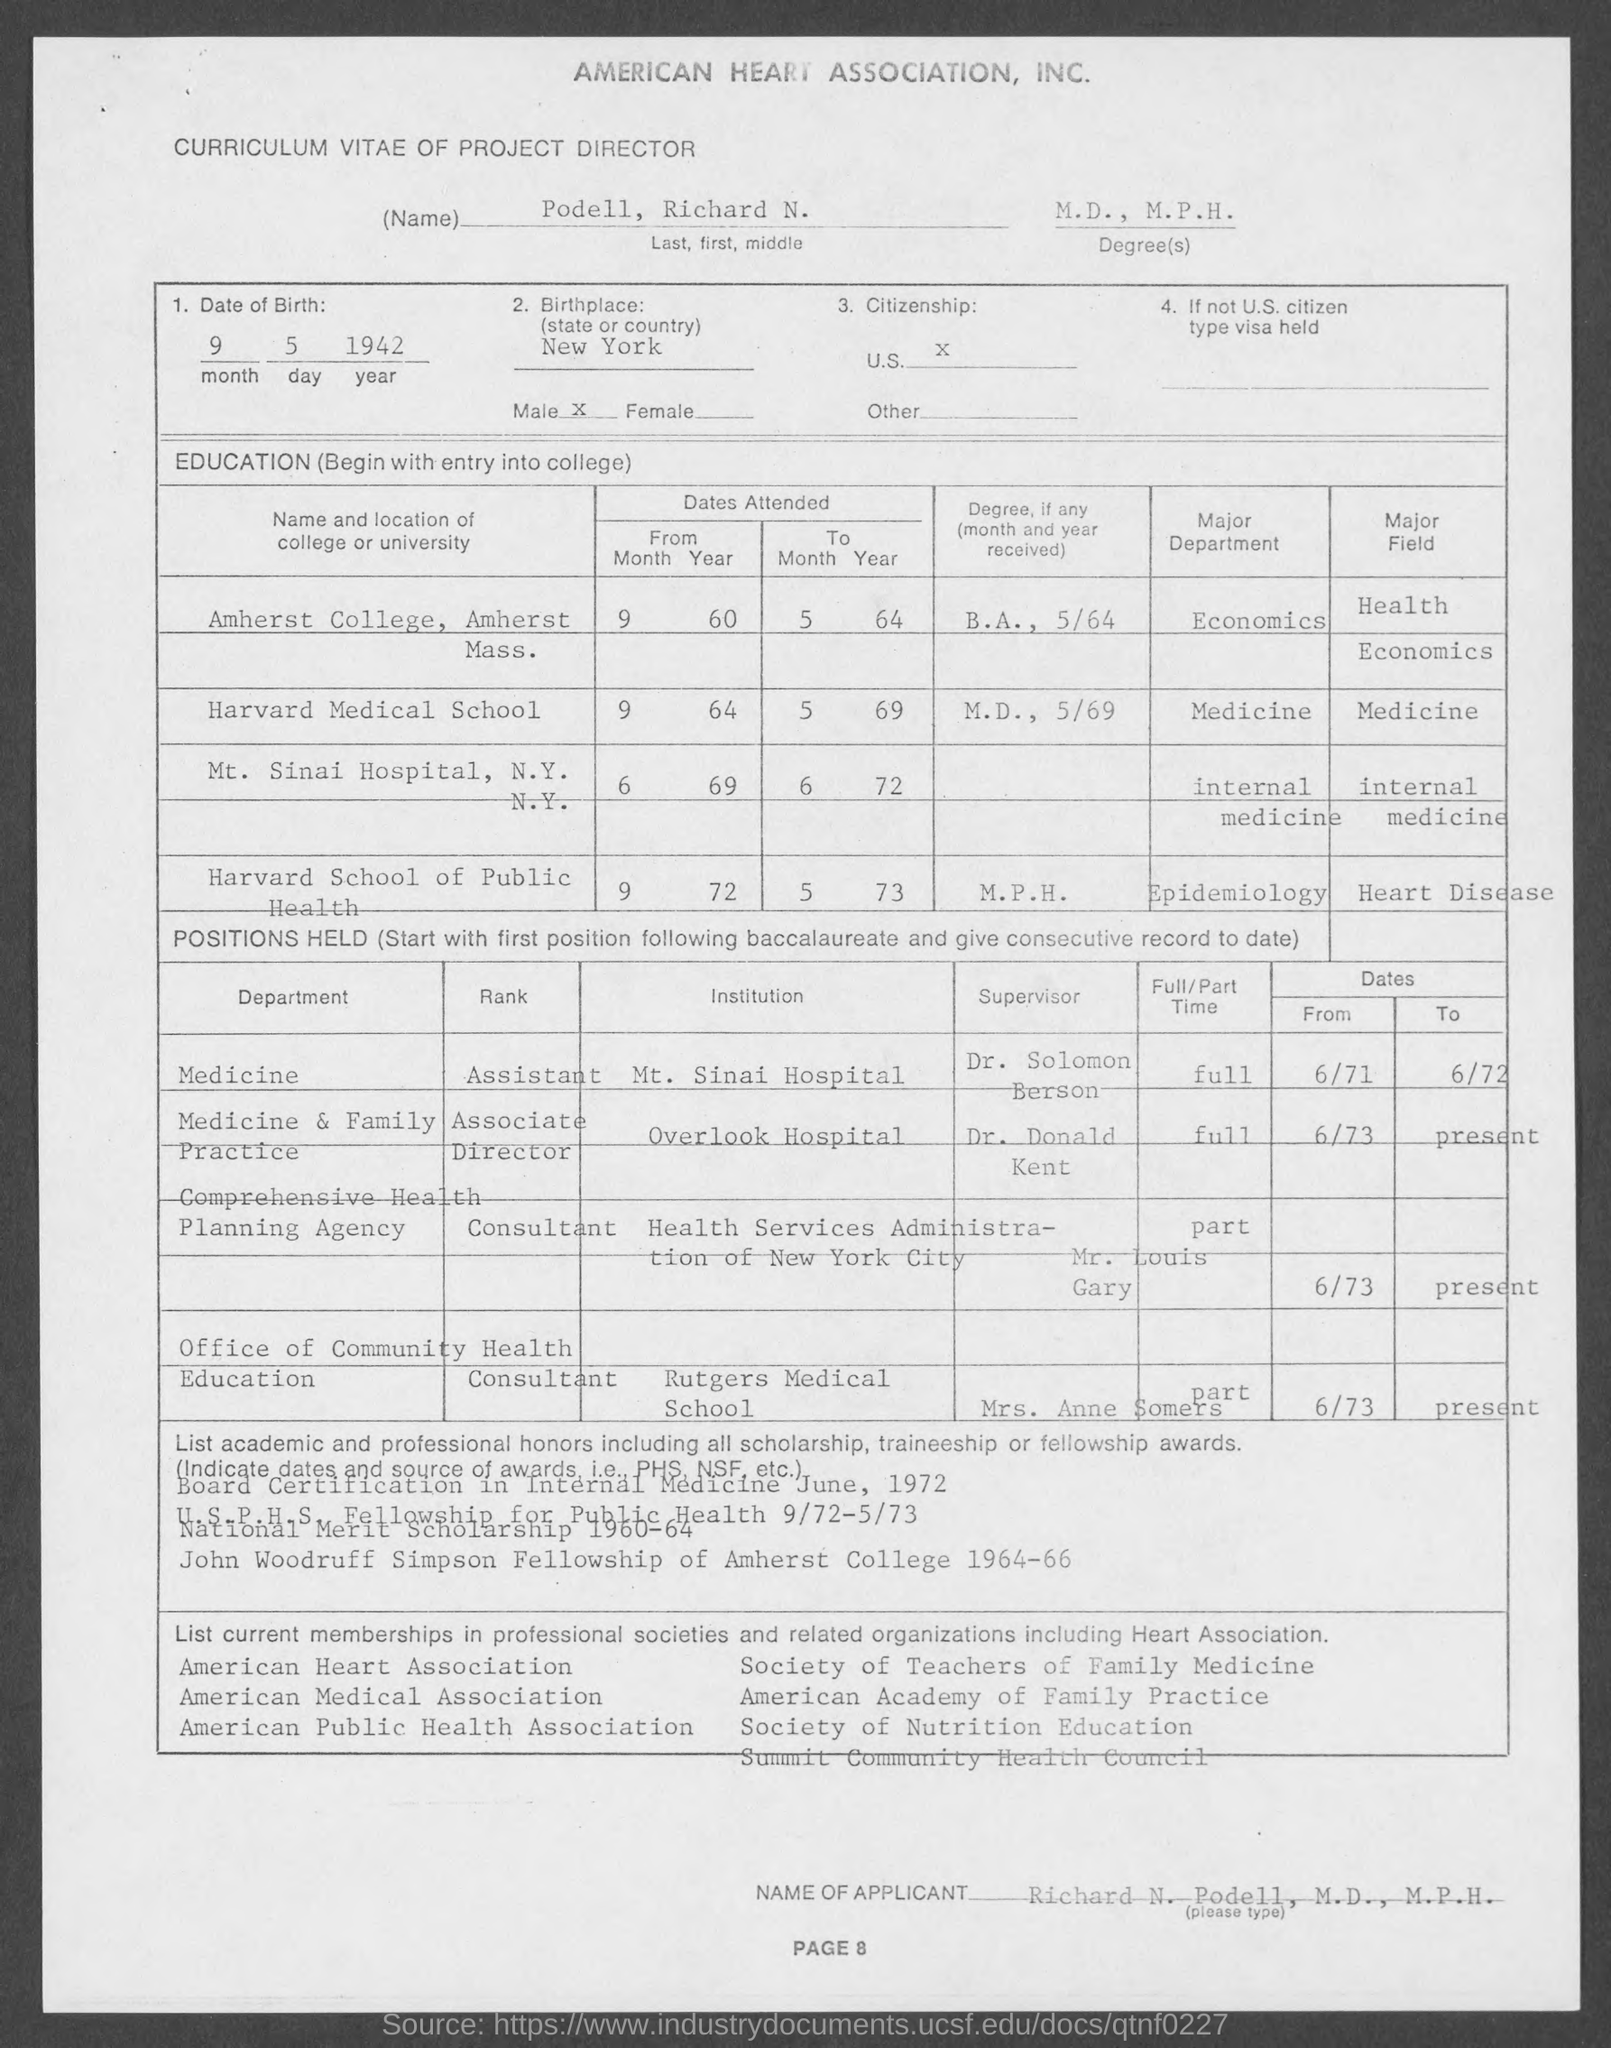List a handful of essential elements in this visual. The degree mentioned in the page is M.D. and M.P.H. The name of the applicant mentioned in the given curriculum vitae is Richard N. Podell. The date of birth mentioned in the given curriculum vitae is September 5, 1942. The name mentioned in the curriculum vitae is "Podell, Richard N...". The given curriculum vitae states that the citizenship is U.S. 